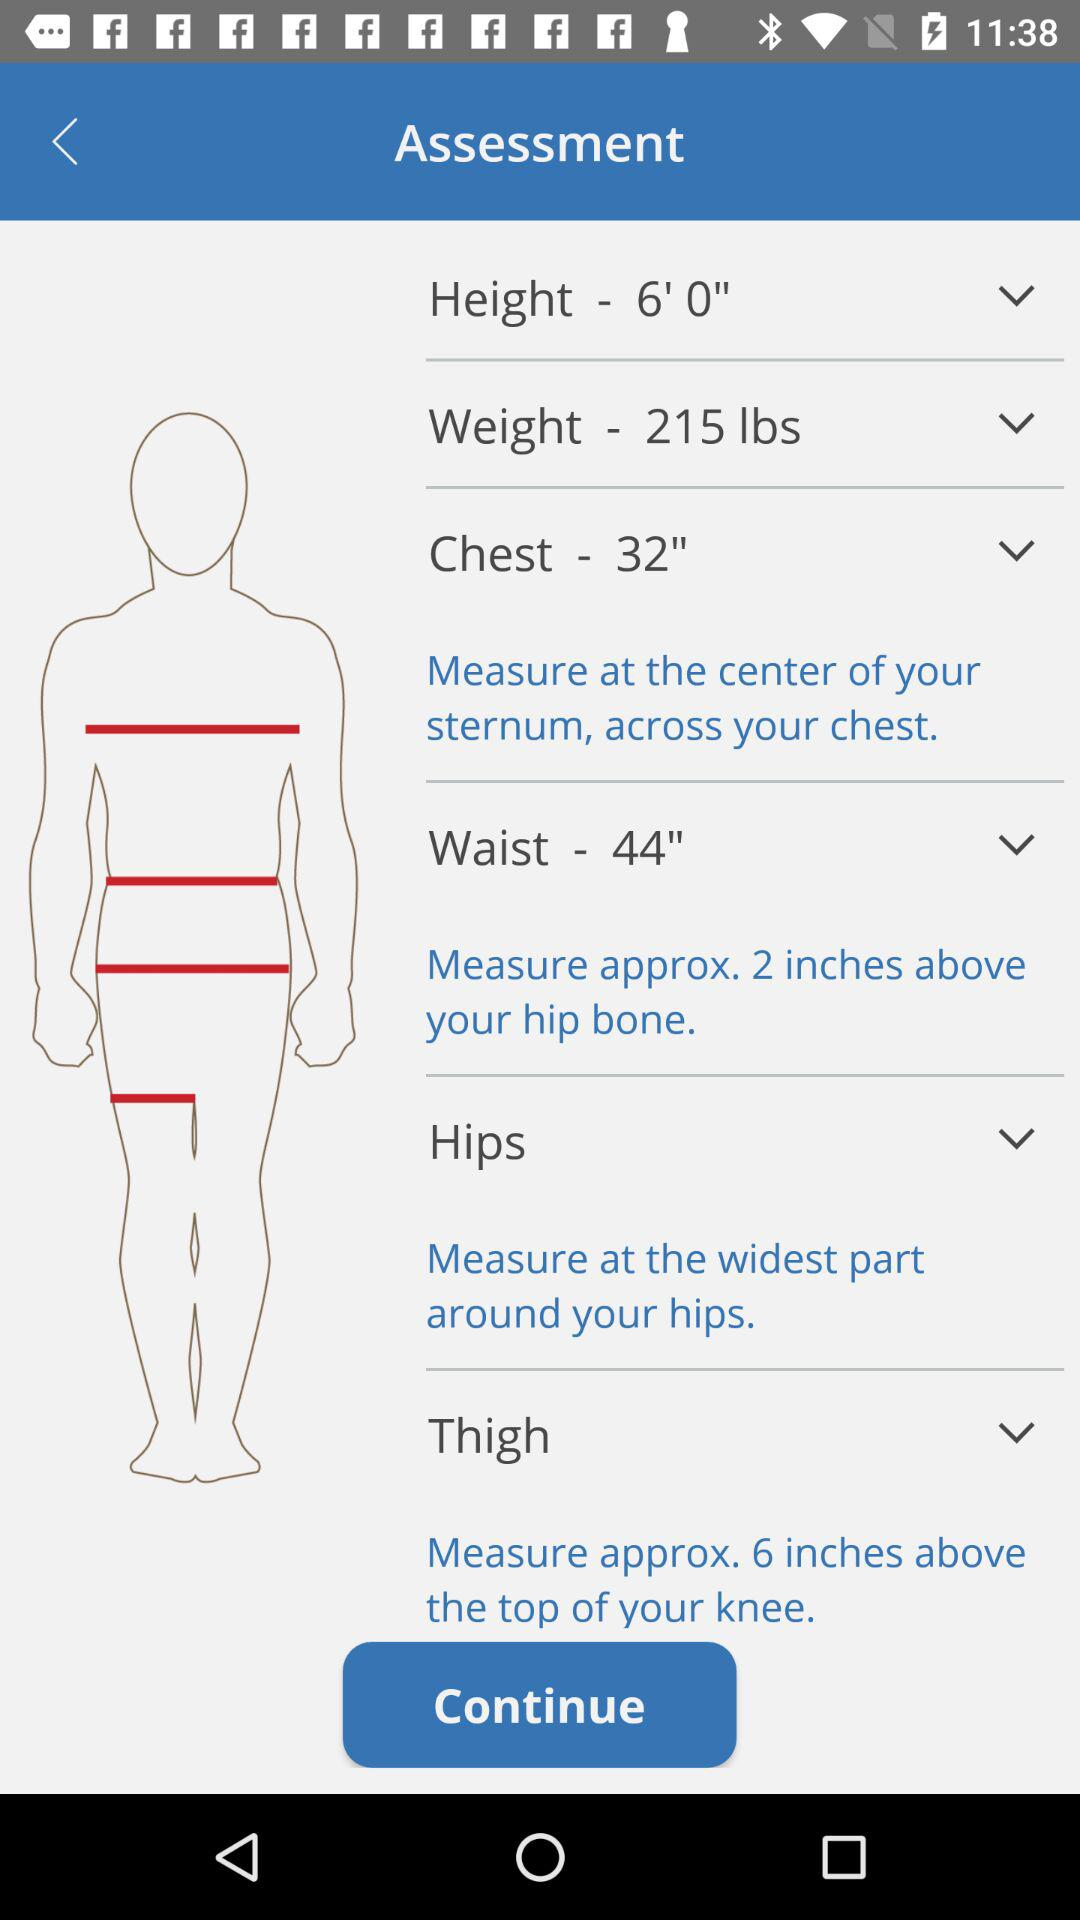Where is the thigh measured? The thigh is measured approximately 6 inches above the top of your knee. 